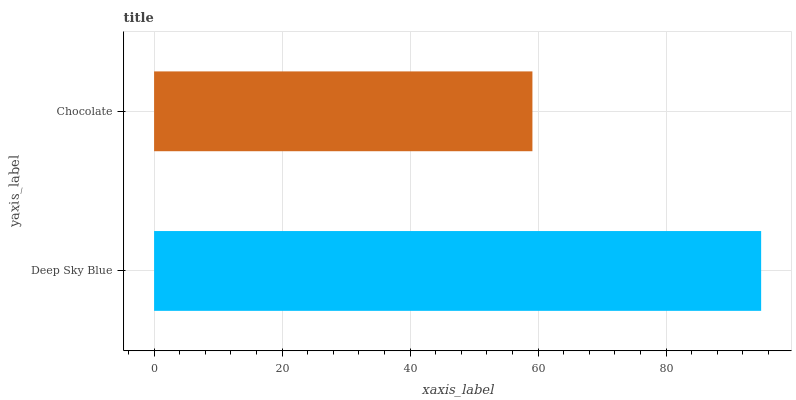Is Chocolate the minimum?
Answer yes or no. Yes. Is Deep Sky Blue the maximum?
Answer yes or no. Yes. Is Chocolate the maximum?
Answer yes or no. No. Is Deep Sky Blue greater than Chocolate?
Answer yes or no. Yes. Is Chocolate less than Deep Sky Blue?
Answer yes or no. Yes. Is Chocolate greater than Deep Sky Blue?
Answer yes or no. No. Is Deep Sky Blue less than Chocolate?
Answer yes or no. No. Is Deep Sky Blue the high median?
Answer yes or no. Yes. Is Chocolate the low median?
Answer yes or no. Yes. Is Chocolate the high median?
Answer yes or no. No. Is Deep Sky Blue the low median?
Answer yes or no. No. 